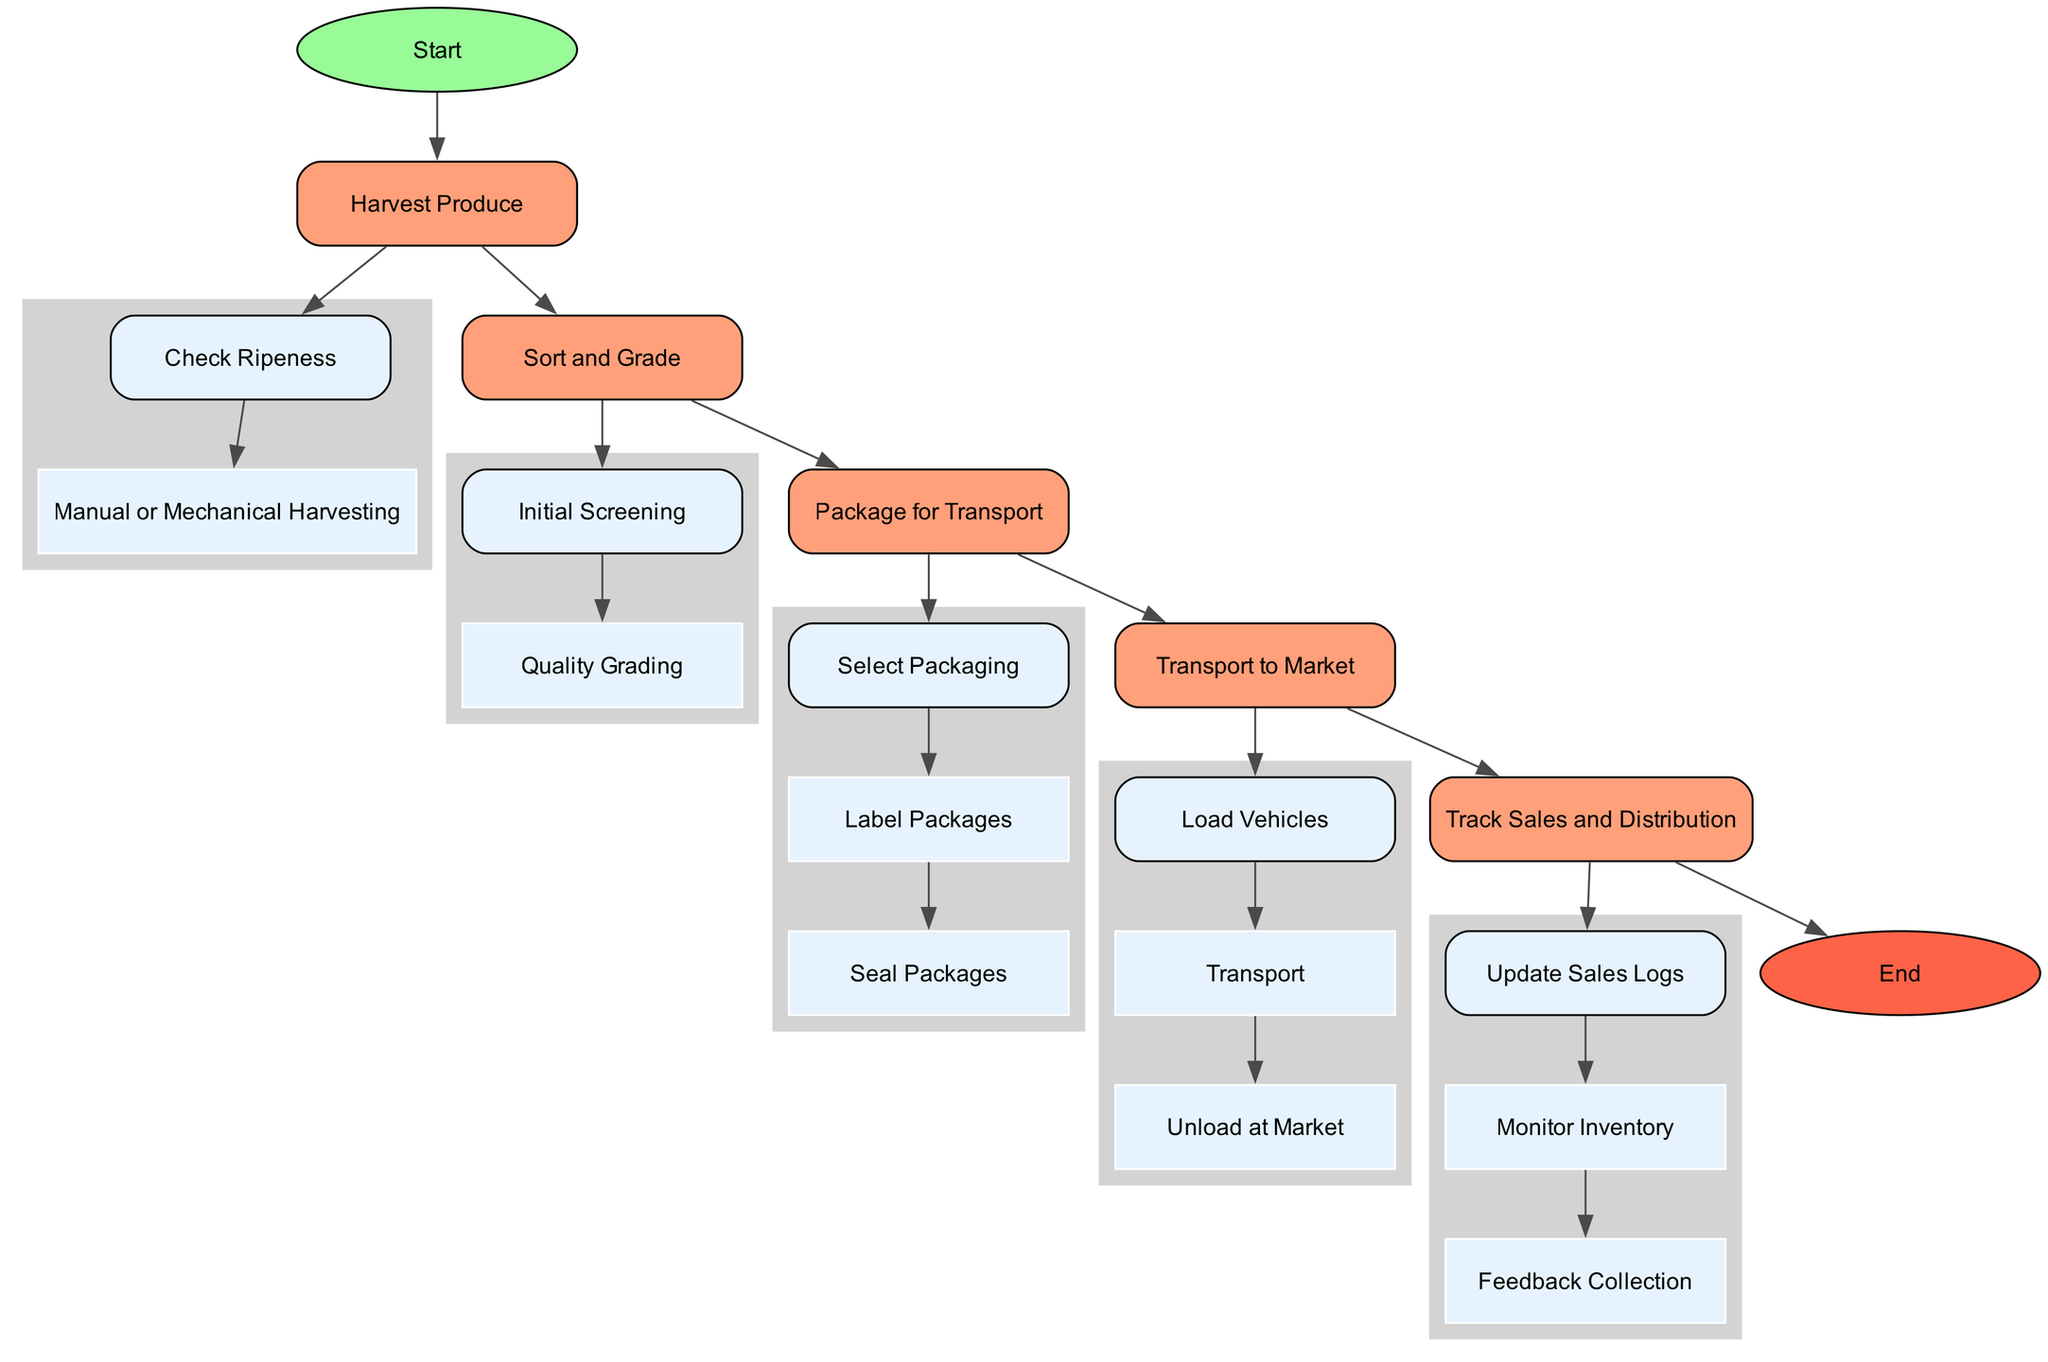What is the first activity in the diagram? The first activity in the diagram, as indicated by the flow from the start node, is "Harvest Produce." There are no other activities before it, making it the initial step.
Answer: Harvest Produce How many total activities are represented in the diagram? There are five activities listed in the diagram: Harvest Produce, Sort and Grade, Package for Transport, Transport to Market, and Track Sales and Distribution. By counting these activities, we find the total number is five.
Answer: 5 What action follows "Sort and Grade"? The diagram shows that after "Sort and Grade," the next activity is "Package for Transport." Identifying the direct relationship between activities leads to this answer.
Answer: Package for Transport How many actions are involved in "Package for Transport"? The "Package for Transport" activity includes three actions: "Select Packaging," "Label Packages," and "Seal Packages." By counting these actions listed within it, we can conclude that there are three actions.
Answer: 3 What is the final activity before the end node? The final activity proceeding to the end node is "Track Sales and Distribution." This is the last defined activity that leads to the conclusion of the diagram.
Answer: Track Sales and Distribution What action comes after "Transport" in the diagram? According to the flow indicated, the "Transport" action is succeeded by "Unload at Market." By tracing the sequence of actions within the "Transport to Market" activity, we find this is the next step.
Answer: Unload at Market What type of feedback is collected in the last activity? The last activity involves the action "Feedback Collection," which specifies that feedback is collected from buyers. This gives insight into how the supply chain can improve based on buyer experiences.
Answer: Feedback Collection What is the primary purpose of the "Track Sales and Distribution" activity? The main aim of the "Track Sales and Distribution" activity is to keep detailed records of sales transactions for traceability, inventory management, and gathering feedback for continuous improvement.
Answer: Traceability 